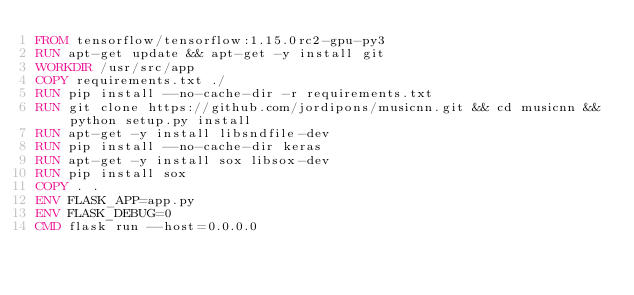<code> <loc_0><loc_0><loc_500><loc_500><_Dockerfile_>FROM tensorflow/tensorflow:1.15.0rc2-gpu-py3
RUN apt-get update && apt-get -y install git
WORKDIR /usr/src/app
COPY requirements.txt ./
RUN pip install --no-cache-dir -r requirements.txt 
RUN git clone https://github.com/jordipons/musicnn.git && cd musicnn && python setup.py install
RUN apt-get -y install libsndfile-dev
RUN pip install --no-cache-dir keras
RUN apt-get -y install sox libsox-dev
RUN pip install sox
COPY . . 
ENV FLASK_APP=app.py
ENV FLASK_DEBUG=0
CMD flask run --host=0.0.0.0</code> 